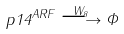<formula> <loc_0><loc_0><loc_500><loc_500>p 1 4 ^ { A R F } \overset { W _ { 8 } } { \longrightarrow } \Phi</formula> 